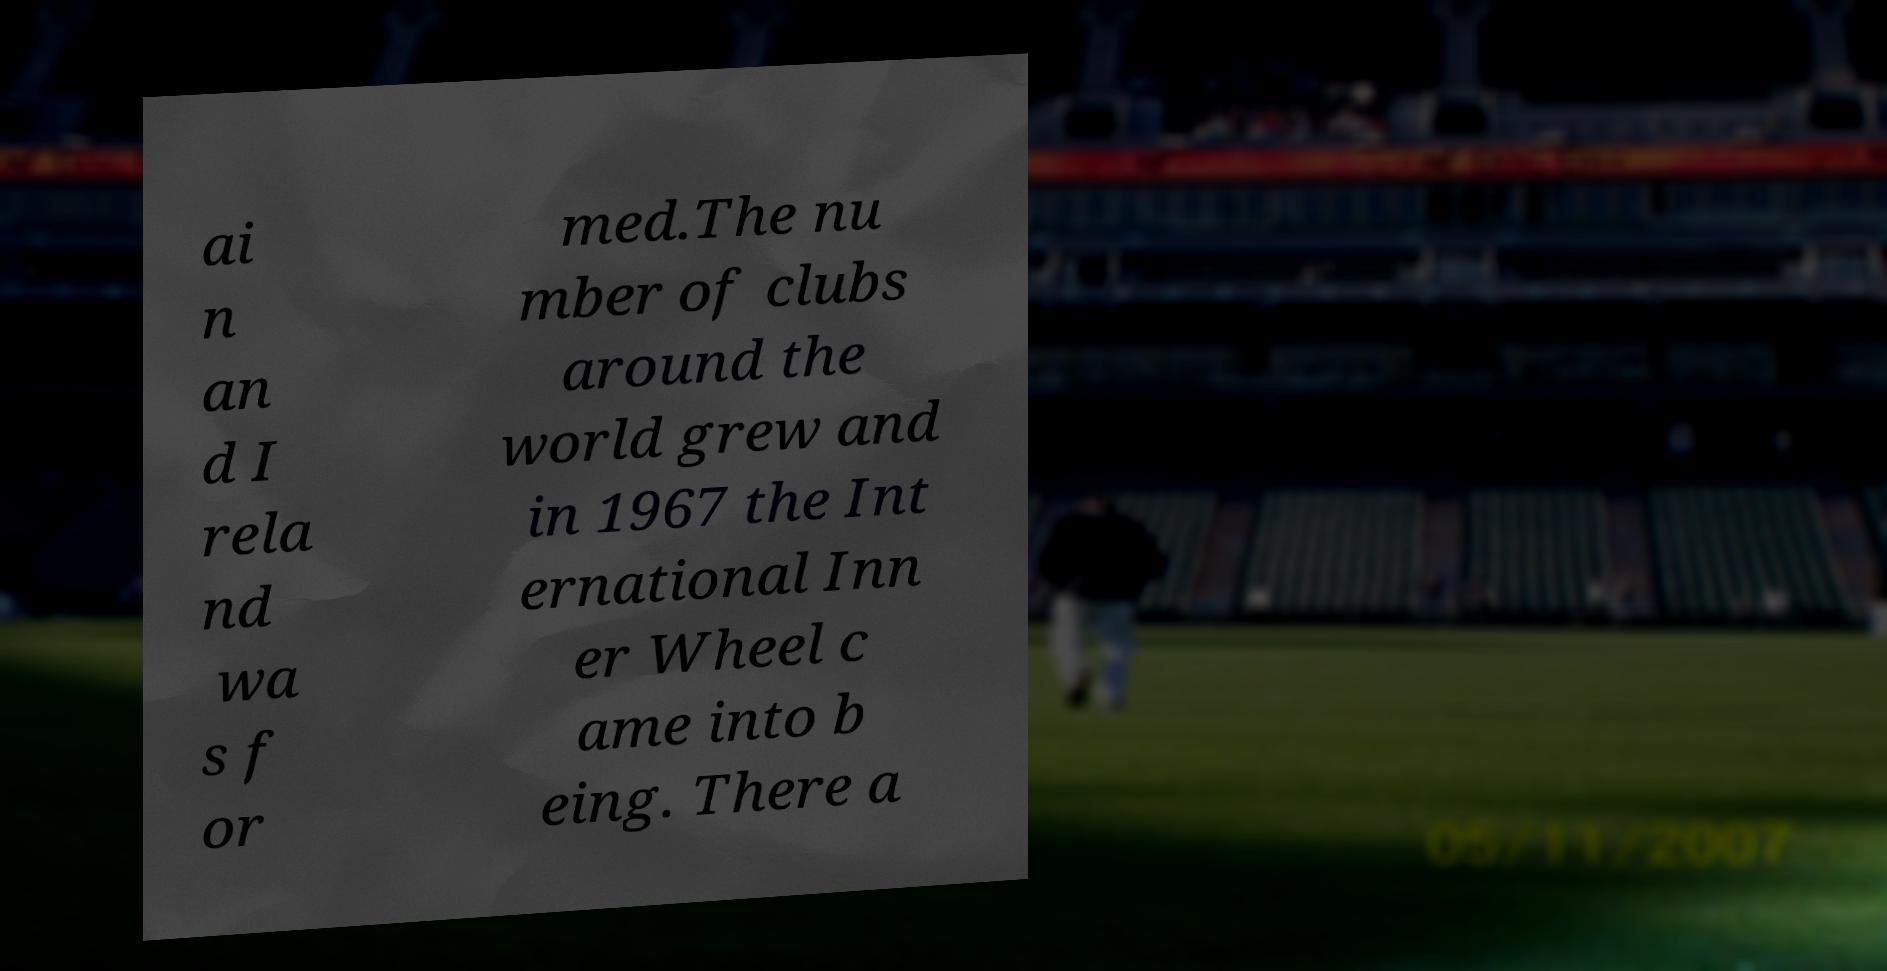What messages or text are displayed in this image? I need them in a readable, typed format. ai n an d I rela nd wa s f or med.The nu mber of clubs around the world grew and in 1967 the Int ernational Inn er Wheel c ame into b eing. There a 